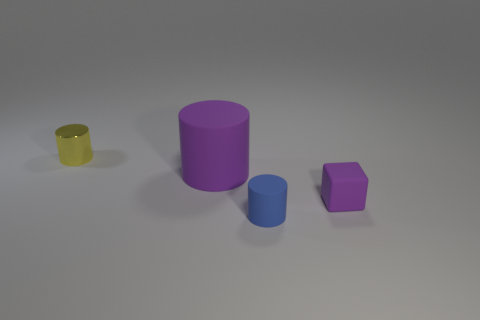Add 2 cylinders. How many objects exist? 6 Subtract all blocks. How many objects are left? 3 Add 1 tiny blocks. How many tiny blocks exist? 2 Subtract 0 green blocks. How many objects are left? 4 Subtract all purple objects. Subtract all things. How many objects are left? 0 Add 3 large purple things. How many large purple things are left? 4 